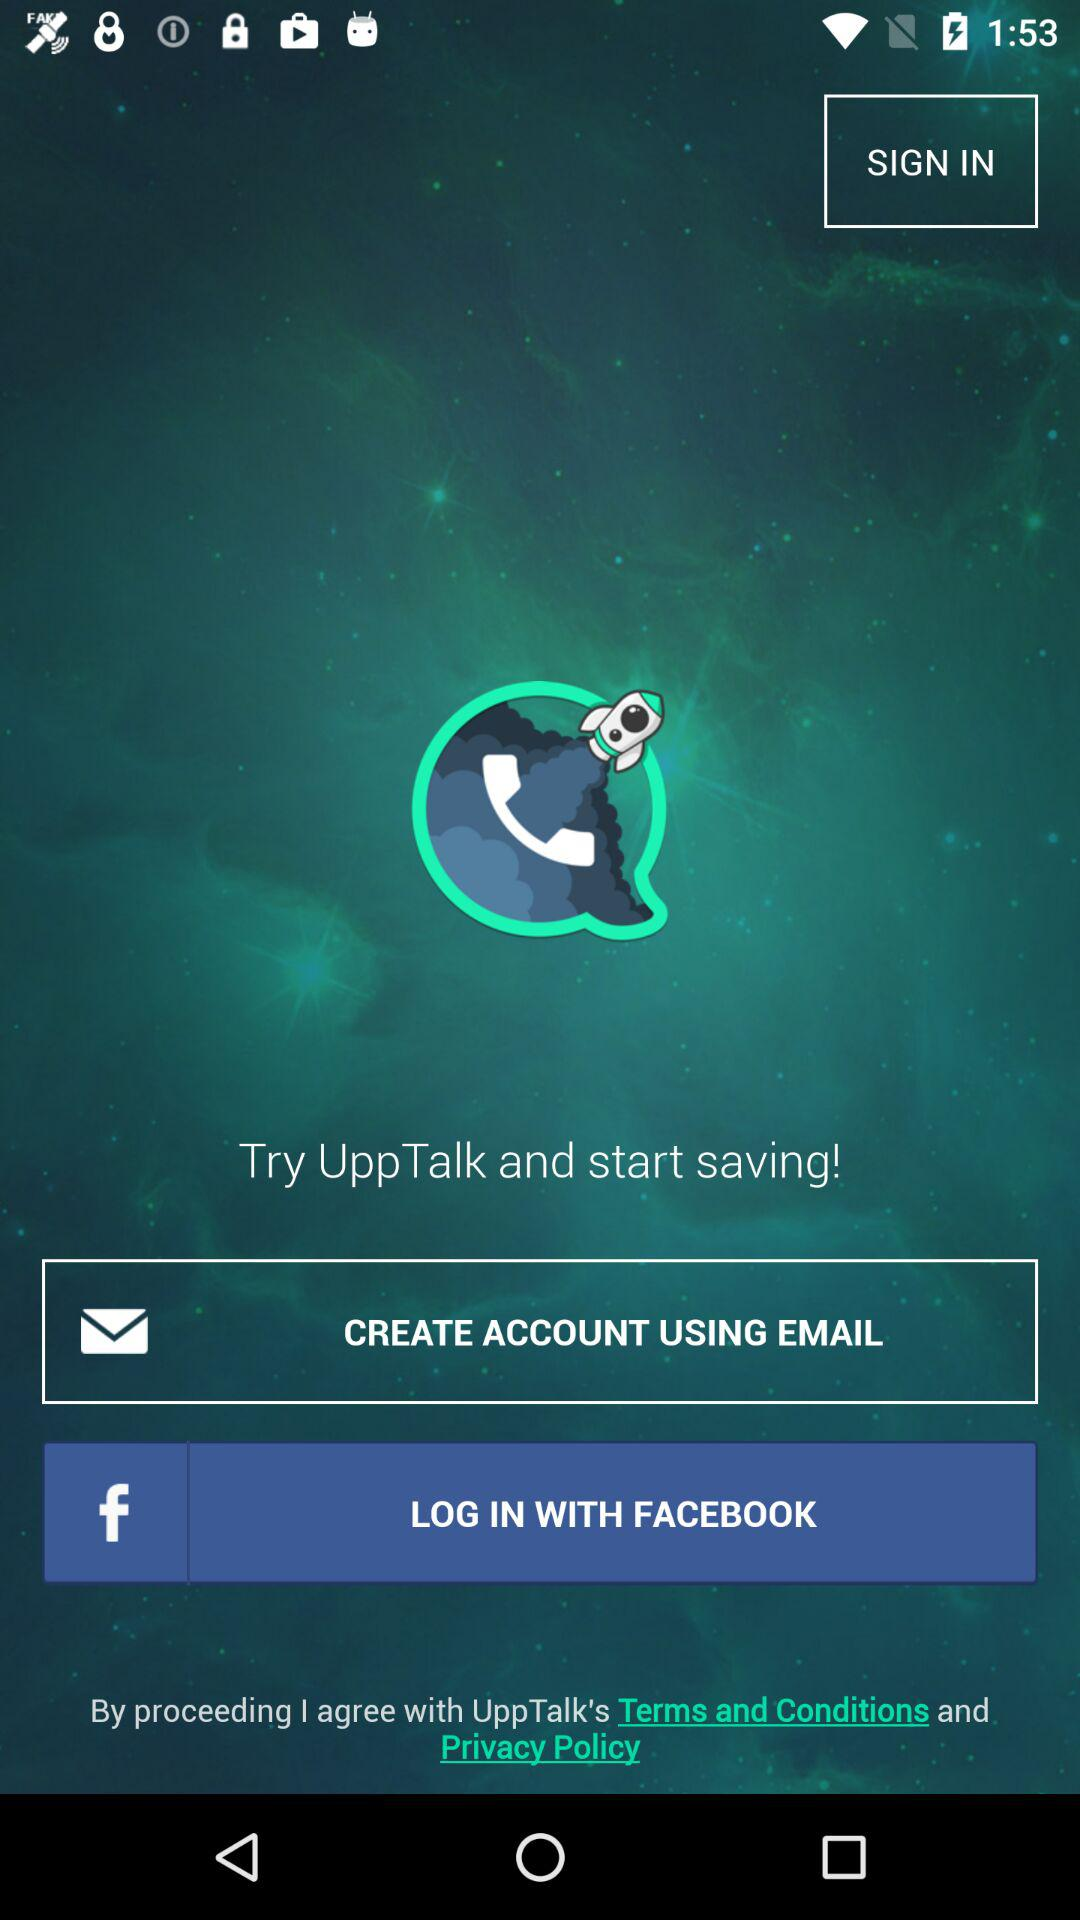What is the app's title? The app's title is "UppTalk". 